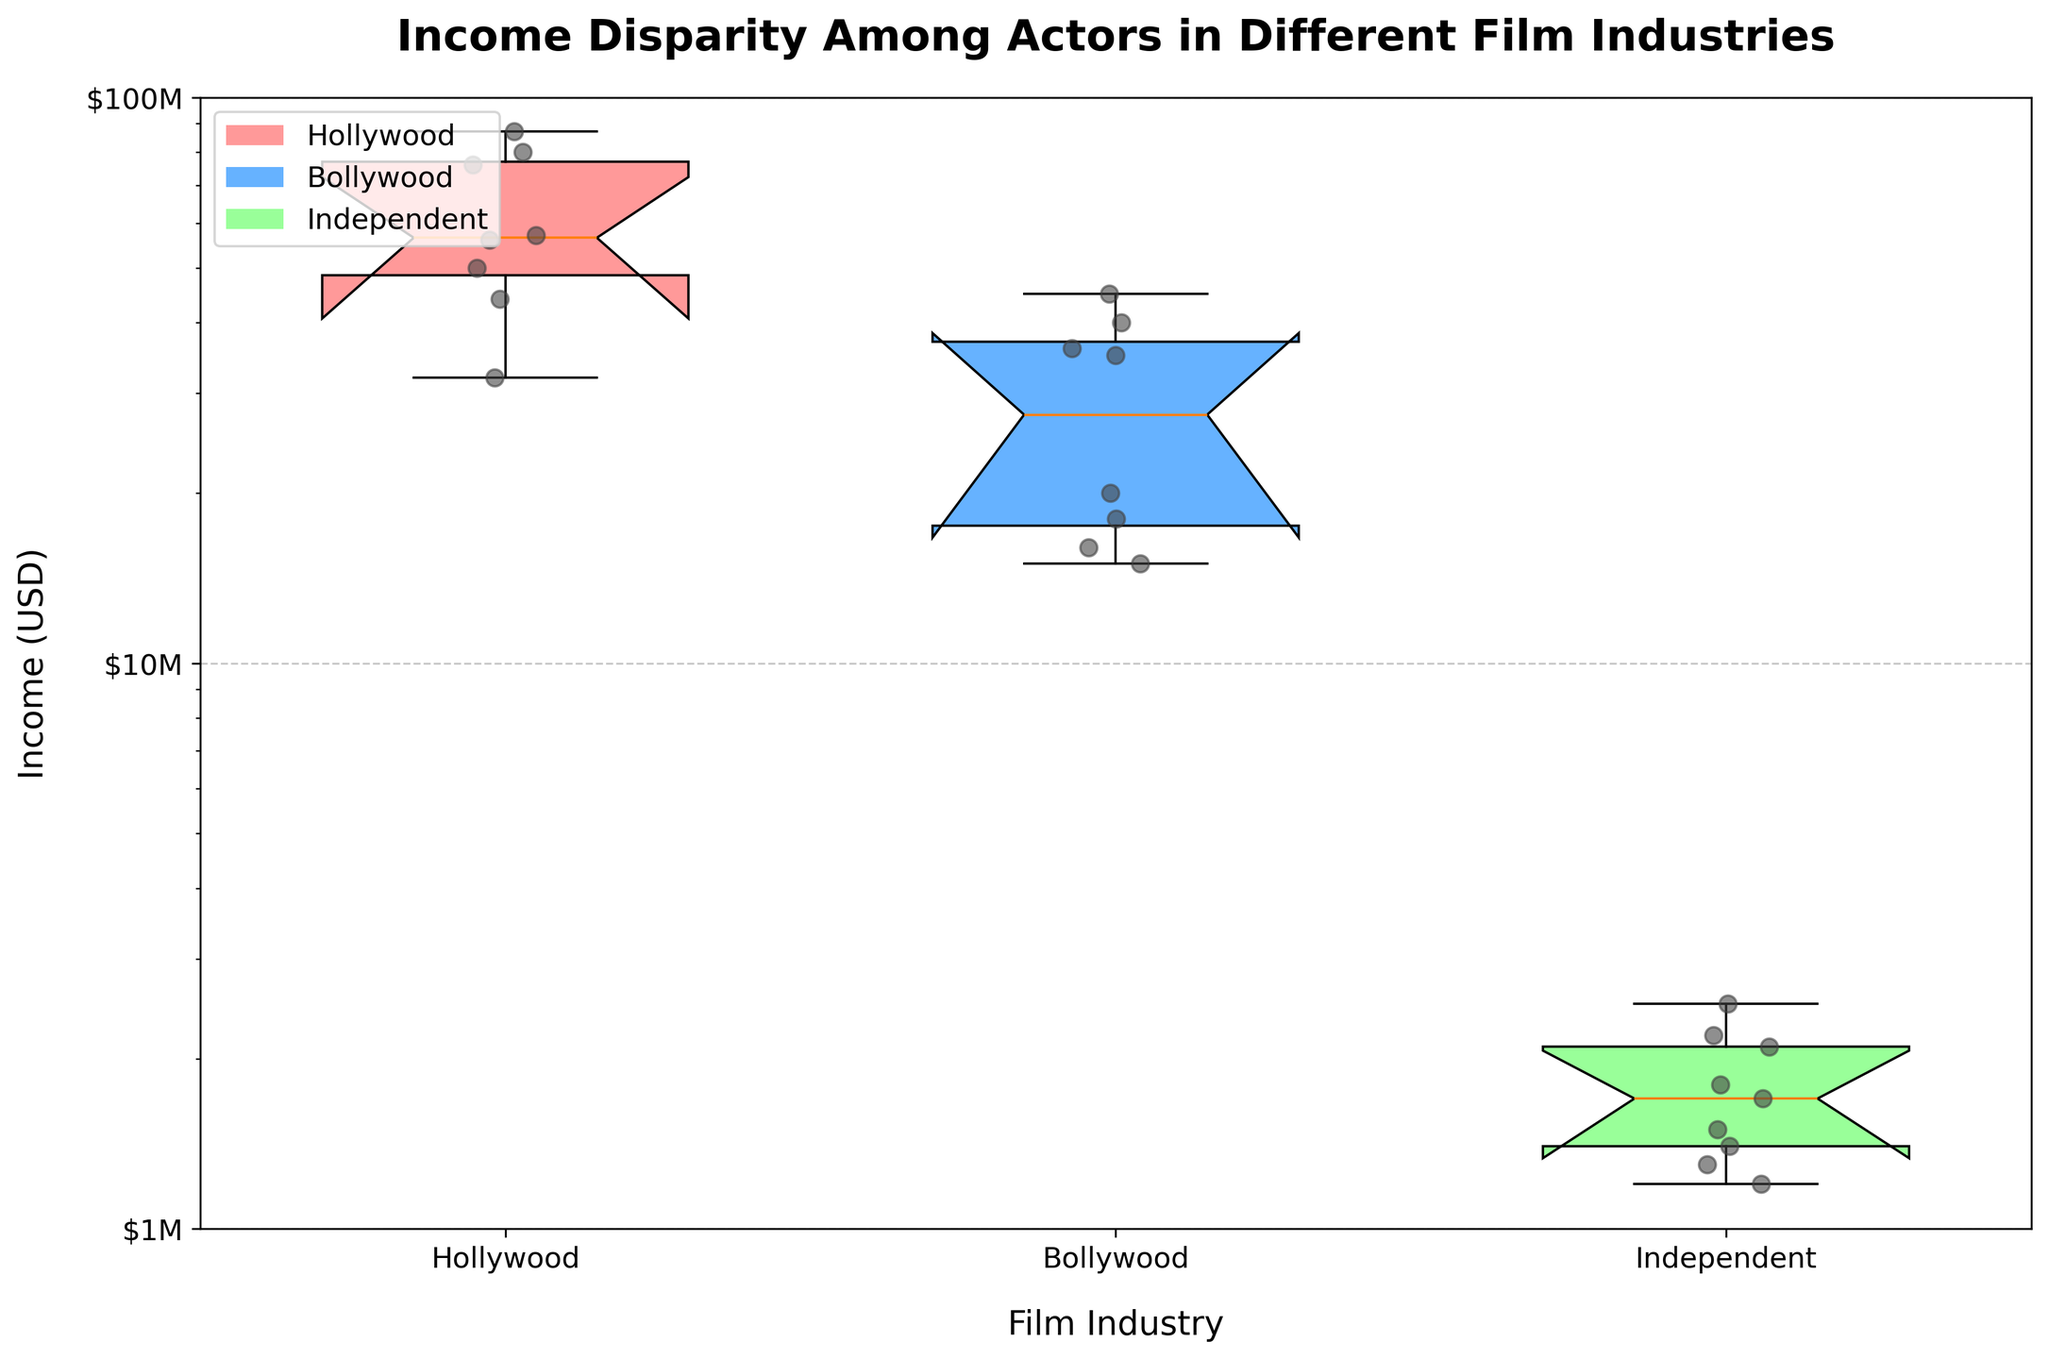What is the title of the plot? The title is located at the top of the plot and reads "Income Disparity Among Actors in Different Film Industries".
Answer: Income Disparity Among Actors in Different Film Industries Which film industry has the highest median income? From the box plots, the median is represented by the centerline of each box. The median for Hollywood is visibly higher than those for Bollywood and Independent industries.
Answer: Hollywood What is the range of incomes in the Hollywood industry? The range can be identified by looking at the ends of the whiskers in the box plot for Hollywood. The range spans from roughly $32M to $87M.
Answer: $32M to $87M Which industry shows the lowest income among actors? By looking at the lower whiskers of the box plots, Independent shows incomes as low as approximately $1.2M, which is lower than the other industries.
Answer: Independent How does the income disparity in the Bollywood industry compare to Independent films? The income range for Bollywood spans from about $15M to $45M, while for Independent films it goes from about $1.2M to $2.5M. Bollywood has a wider range, indicating greater disparity.
Answer: Wider in Bollywood Between Hollywood and Bollywood, which industry has the smallest interquartile range (IQR)? The IQR is represented by the height of the box. Hollywood has a smaller IQR than Bollywood, indicating a smaller range between the first and third quartiles.
Answer: Hollywood What can you infer about Bollywood's income distribution based on the presence of outliers? The figure indicates that Bollywood does not show any significant outliers beyond the whiskers, suggesting a more concentrated income distribution compared to other industries.
Answer: Concentrated distribution In the context of income disparity, what does the length of the whiskers signify in these box plots? Whiskers represent the range of the data. Longer whiskers indicate a wider range of incomes, reflecting greater income disparity within that industry.
Answer: Income disparity How does the mean income in Independent films compare to the median income in Hollywood? The mean in Independent films can be inferred from the cluster of points and is around $1.8M. The median in Hollywood is marked by the middle line of its box, which is around $56M. The mean income in Independent films is much lower than the median income in Hollywood.
Answer: Much lower 